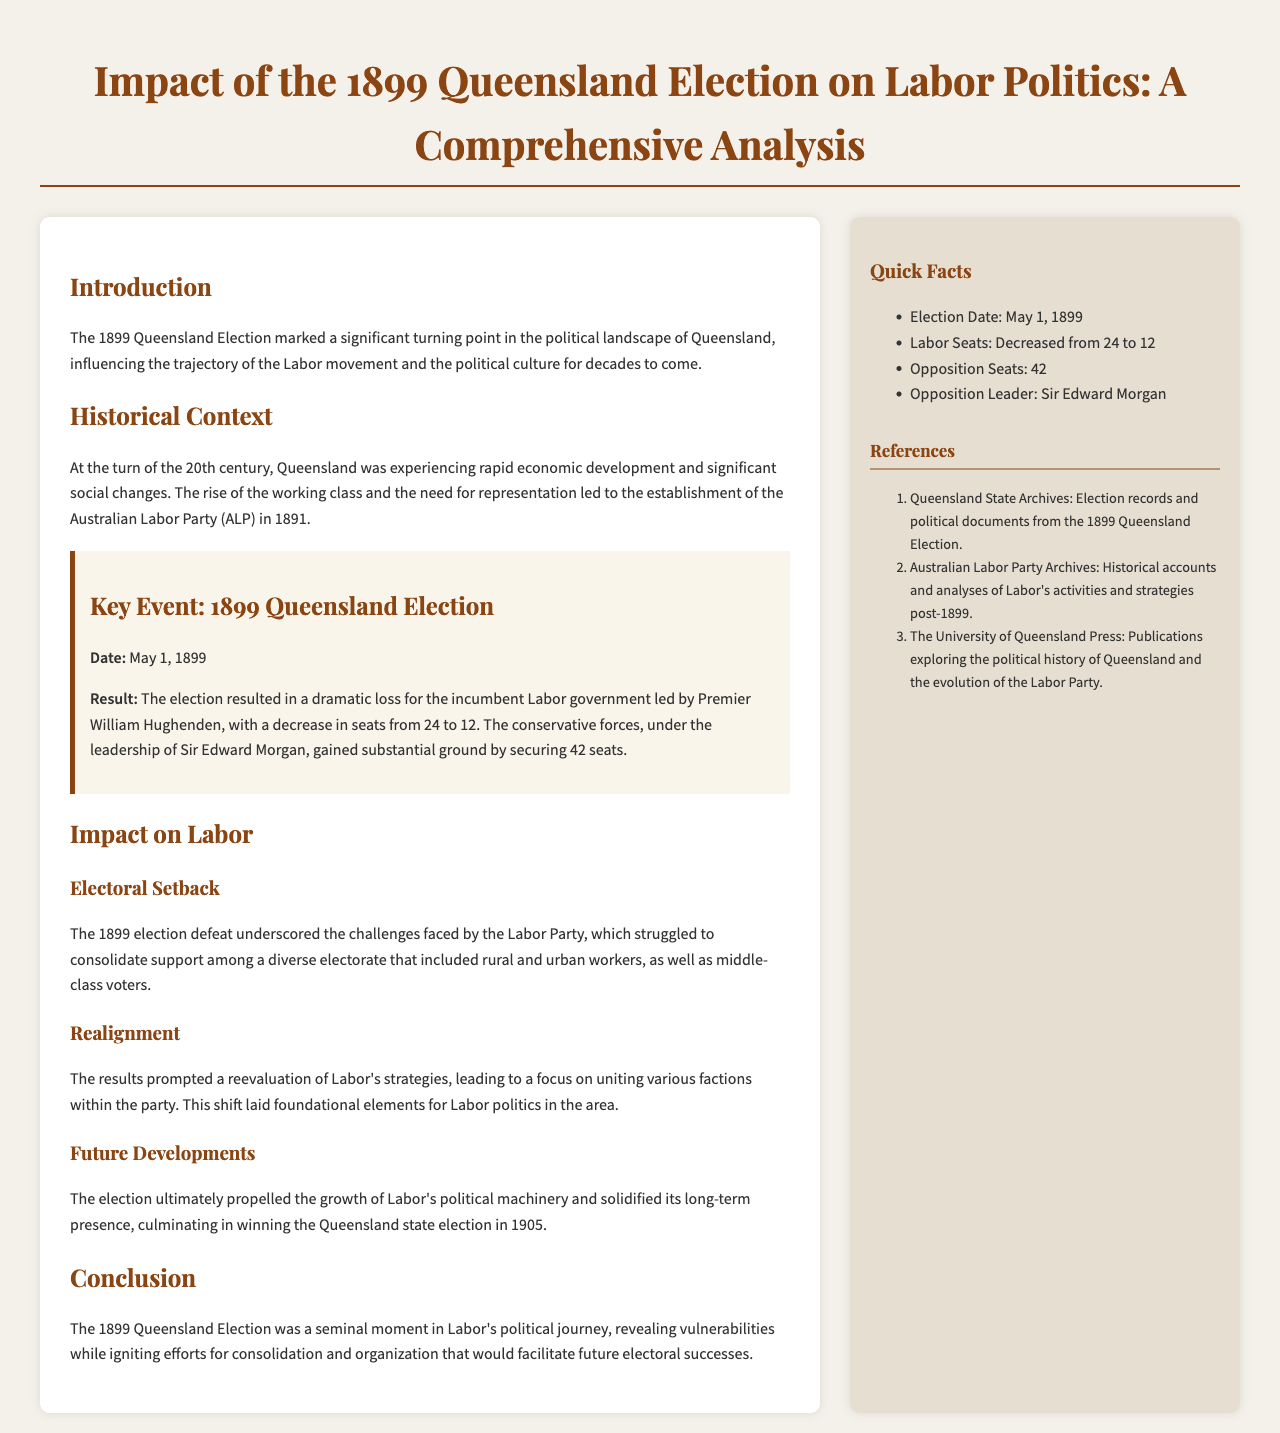What significant political event does the document analyze? The document analyzes the 1899 Queensland Election and its impact on Labor politics.
Answer: 1899 Queensland Election What was the date of the 1899 Queensland Election? The document specifies the date of the election as May 1, 1899.
Answer: May 1, 1899 How many seats did the Labor Party have before the election? The Labor Party had 24 seats before the election, as mentioned in the document.
Answer: 24 Who was the opposition leader during the 1899 Queensland Election? The document identifies Sir Edward Morgan as the opposition leader.
Answer: Sir Edward Morgan What was the result of the election for the Labor Party? The Labor Party lost seats, decreasing from 24 to 12, as detailed in the document.
Answer: Decreased from 24 to 12 What prompted the Labor Party to reevaluate its strategies? The election results, which showed a dramatic loss for the Labor Party, prompted this reevaluation.
Answer: Election results What significant political change occurred as a result of the 1899 election? The results led to a focus on uniting various factions within the Labor Party.
Answer: Focus on uniting factions In what year did the Labor Party win the Queensland state election following the 1899 election? The Labor Party won the election in 1905, according to the document.
Answer: 1905 What is the main conclusion drawn in the document about the 1899 Queensland Election? The conclusion states it was a seminal moment for Labor, revealing vulnerabilities and igniting consolidation efforts.
Answer: Seminal moment for Labor 